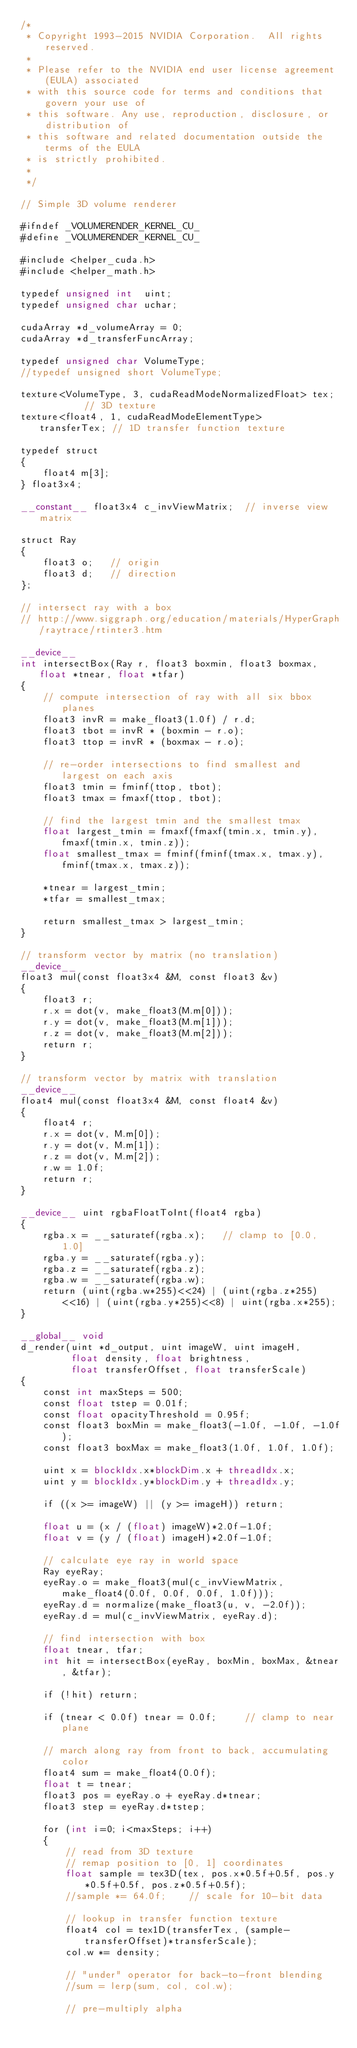Convert code to text. <code><loc_0><loc_0><loc_500><loc_500><_Cuda_>/*
 * Copyright 1993-2015 NVIDIA Corporation.  All rights reserved.
 *
 * Please refer to the NVIDIA end user license agreement (EULA) associated
 * with this source code for terms and conditions that govern your use of
 * this software. Any use, reproduction, disclosure, or distribution of
 * this software and related documentation outside the terms of the EULA
 * is strictly prohibited.
 *
 */

// Simple 3D volume renderer

#ifndef _VOLUMERENDER_KERNEL_CU_
#define _VOLUMERENDER_KERNEL_CU_

#include <helper_cuda.h>
#include <helper_math.h>

typedef unsigned int  uint;
typedef unsigned char uchar;

cudaArray *d_volumeArray = 0;
cudaArray *d_transferFuncArray;

typedef unsigned char VolumeType;
//typedef unsigned short VolumeType;

texture<VolumeType, 3, cudaReadModeNormalizedFloat> tex;         // 3D texture
texture<float4, 1, cudaReadModeElementType>         transferTex; // 1D transfer function texture

typedef struct
{
    float4 m[3];
} float3x4;

__constant__ float3x4 c_invViewMatrix;  // inverse view matrix

struct Ray
{
    float3 o;   // origin
    float3 d;   // direction
};

// intersect ray with a box
// http://www.siggraph.org/education/materials/HyperGraph/raytrace/rtinter3.htm

__device__
int intersectBox(Ray r, float3 boxmin, float3 boxmax, float *tnear, float *tfar)
{
    // compute intersection of ray with all six bbox planes
    float3 invR = make_float3(1.0f) / r.d;
    float3 tbot = invR * (boxmin - r.o);
    float3 ttop = invR * (boxmax - r.o);

    // re-order intersections to find smallest and largest on each axis
    float3 tmin = fminf(ttop, tbot);
    float3 tmax = fmaxf(ttop, tbot);

    // find the largest tmin and the smallest tmax
    float largest_tmin = fmaxf(fmaxf(tmin.x, tmin.y), fmaxf(tmin.x, tmin.z));
    float smallest_tmax = fminf(fminf(tmax.x, tmax.y), fminf(tmax.x, tmax.z));

    *tnear = largest_tmin;
    *tfar = smallest_tmax;

    return smallest_tmax > largest_tmin;
}

// transform vector by matrix (no translation)
__device__
float3 mul(const float3x4 &M, const float3 &v)
{
    float3 r;
    r.x = dot(v, make_float3(M.m[0]));
    r.y = dot(v, make_float3(M.m[1]));
    r.z = dot(v, make_float3(M.m[2]));
    return r;
}

// transform vector by matrix with translation
__device__
float4 mul(const float3x4 &M, const float4 &v)
{
    float4 r;
    r.x = dot(v, M.m[0]);
    r.y = dot(v, M.m[1]);
    r.z = dot(v, M.m[2]);
    r.w = 1.0f;
    return r;
}

__device__ uint rgbaFloatToInt(float4 rgba)
{
    rgba.x = __saturatef(rgba.x);   // clamp to [0.0, 1.0]
    rgba.y = __saturatef(rgba.y);
    rgba.z = __saturatef(rgba.z);
    rgba.w = __saturatef(rgba.w);
    return (uint(rgba.w*255)<<24) | (uint(rgba.z*255)<<16) | (uint(rgba.y*255)<<8) | uint(rgba.x*255);
}

__global__ void
d_render(uint *d_output, uint imageW, uint imageH,
         float density, float brightness,
         float transferOffset, float transferScale)
{
    const int maxSteps = 500;
    const float tstep = 0.01f;
    const float opacityThreshold = 0.95f;
    const float3 boxMin = make_float3(-1.0f, -1.0f, -1.0f);
    const float3 boxMax = make_float3(1.0f, 1.0f, 1.0f);

    uint x = blockIdx.x*blockDim.x + threadIdx.x;
    uint y = blockIdx.y*blockDim.y + threadIdx.y;

    if ((x >= imageW) || (y >= imageH)) return;

    float u = (x / (float) imageW)*2.0f-1.0f;
    float v = (y / (float) imageH)*2.0f-1.0f;

    // calculate eye ray in world space
    Ray eyeRay;
    eyeRay.o = make_float3(mul(c_invViewMatrix, make_float4(0.0f, 0.0f, 0.0f, 1.0f)));
    eyeRay.d = normalize(make_float3(u, v, -2.0f));
    eyeRay.d = mul(c_invViewMatrix, eyeRay.d);

    // find intersection with box
    float tnear, tfar;
    int hit = intersectBox(eyeRay, boxMin, boxMax, &tnear, &tfar);

    if (!hit) return;

    if (tnear < 0.0f) tnear = 0.0f;     // clamp to near plane

    // march along ray from front to back, accumulating color
    float4 sum = make_float4(0.0f);
    float t = tnear;
    float3 pos = eyeRay.o + eyeRay.d*tnear;
    float3 step = eyeRay.d*tstep;

    for (int i=0; i<maxSteps; i++)
    {
        // read from 3D texture
        // remap position to [0, 1] coordinates
        float sample = tex3D(tex, pos.x*0.5f+0.5f, pos.y*0.5f+0.5f, pos.z*0.5f+0.5f);
        //sample *= 64.0f;    // scale for 10-bit data

        // lookup in transfer function texture
        float4 col = tex1D(transferTex, (sample-transferOffset)*transferScale);
        col.w *= density;

        // "under" operator for back-to-front blending
        //sum = lerp(sum, col, col.w);

        // pre-multiply alpha</code> 